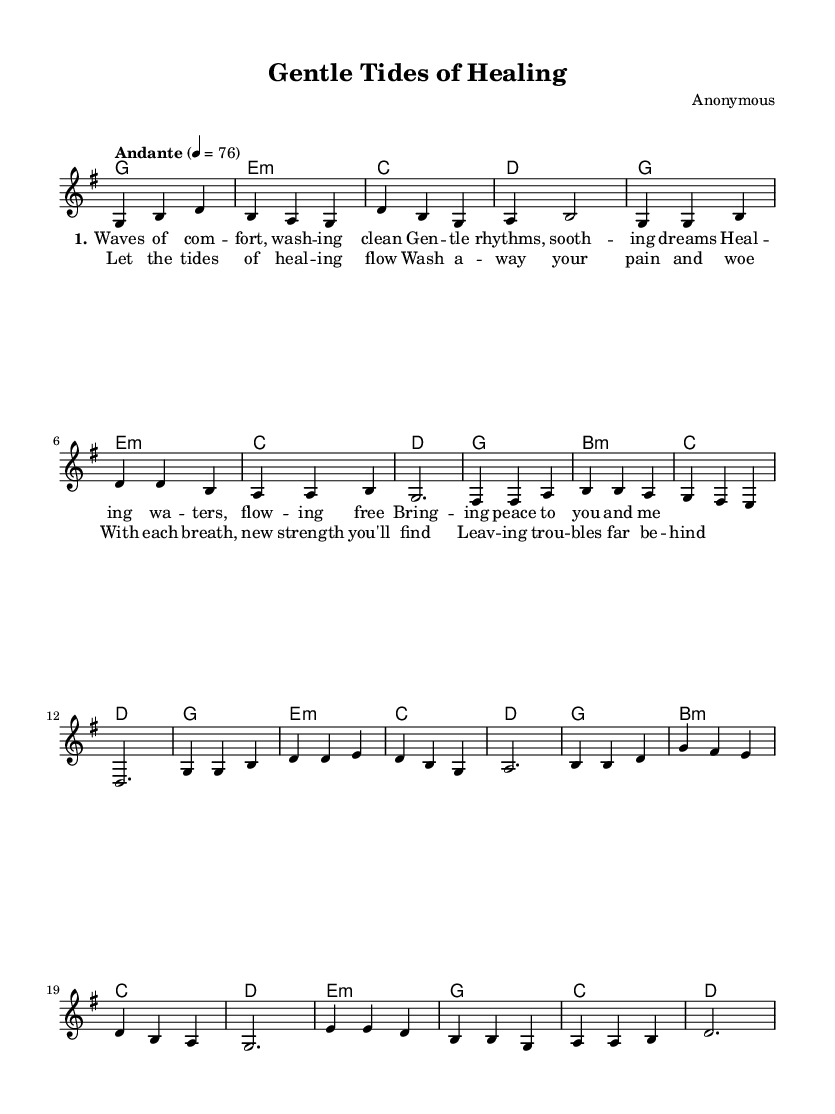What is the key signature of this music? The key signature shown in the music indicates G major, which has one sharp (F#). The indication is typically found at the beginning of the staff.
Answer: G major What is the time signature of this music? The time signature is located at the beginning of the score after the key signature and indicates that there are three beats per measure, represented by "3/4".
Answer: 3/4 What is the tempo marking of this music? The tempo marking is present above the staff and indicates the speed at which the music should be played. It reads "Andante" with a metronome marking of 76, suggesting a moderate pace.
Answer: Andante How many verses does this song have, according to the lyrics? The song structure shows a single verse labeled with "1." followed by a chorus, indicating that this piece contains one verse.
Answer: 1 What is the first note of the melody? The first note of the melody can be found at the very start of the music. It is a G note, located on the second line from the bottom of the staff.
Answer: G What is the function of the harmonies in this folk ballad? The harmonies provide chordal support to the melody and illustrate typical folk music structure, which often includes chord progressions that enhance the emotional quality of the lyrical content. The harmonious chords contribute to the overall soothing theme of the ballad.
Answer: Chordal support What type of structure is employed in the music? The structure is often characterized by a verse-chorus form, which is a common practice in folk music. The initial verse introduces the theme, followed by a chorus that reinforces the message of healing and recovery.
Answer: Verse-chorus 